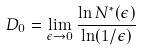Convert formula to latex. <formula><loc_0><loc_0><loc_500><loc_500>D _ { 0 } = \lim _ { \epsilon \to 0 } \frac { \ln N ^ { * } ( \epsilon ) } { \ln ( 1 / \epsilon ) }</formula> 